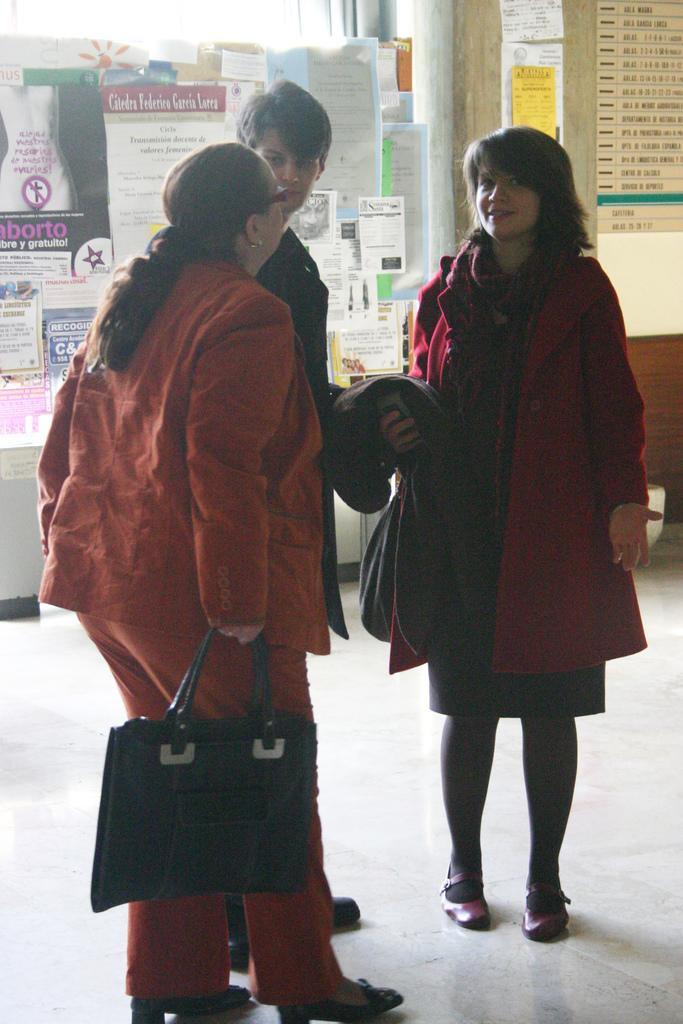How many people are present in the image? There are three people standing on the floor in the image. What is the woman holding in her hand? The woman is holding a bag in her hand. What can be seen in the background of the image? There are posters and a wall in the background. What type of coil is being used by the people in the image? There is no coil present in the image. How many snails can be seen crawling on the wall in the image? There are no snails visible in the image; only posters and a wall are present in the background. 